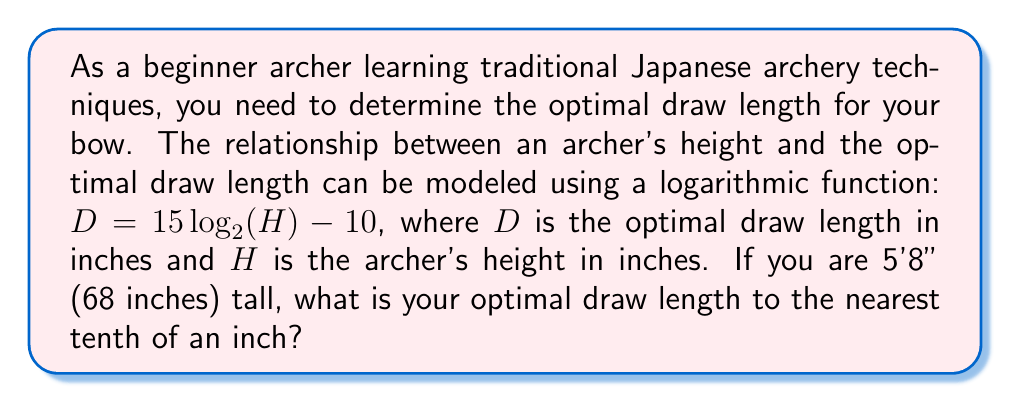Teach me how to tackle this problem. Let's solve this problem step-by-step:

1) We are given the formula: $D = 15 \log_2(H) - 10$
   Where $D$ is the optimal draw length in inches and $H$ is the archer's height in inches.

2) We know the archer's height is 5'8", which is 68 inches.

3) Let's substitute $H = 68$ into the formula:
   $D = 15 \log_2(68) - 10$

4) Now, we need to calculate $\log_2(68)$:
   $\log_2(68) \approx 6.0875$

5) Let's substitute this value back into our equation:
   $D = 15(6.0875) - 10$

6) Multiply:
   $D = 91.3125 - 10$

7) Subtract:
   $D = 81.3125$

8) Rounding to the nearest tenth:
   $D \approx 81.3$ inches

Therefore, the optimal draw length for an archer who is 5'8" tall is approximately 81.3 inches.
Answer: 81.3 inches 